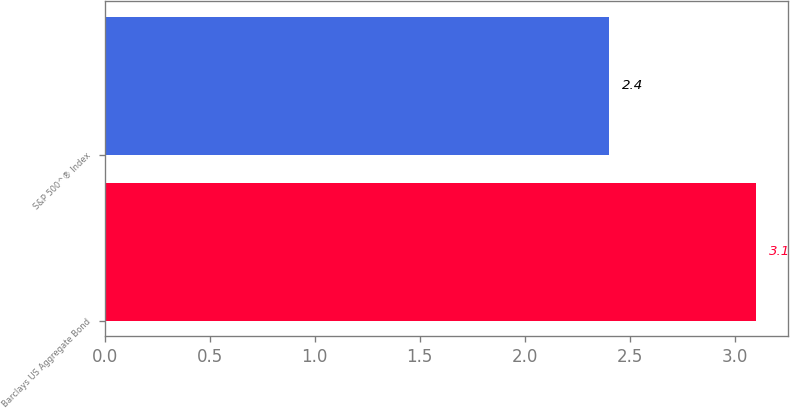Convert chart to OTSL. <chart><loc_0><loc_0><loc_500><loc_500><bar_chart><fcel>Barclays US Aggregate Bond<fcel>S&P 500^® Index<nl><fcel>3.1<fcel>2.4<nl></chart> 